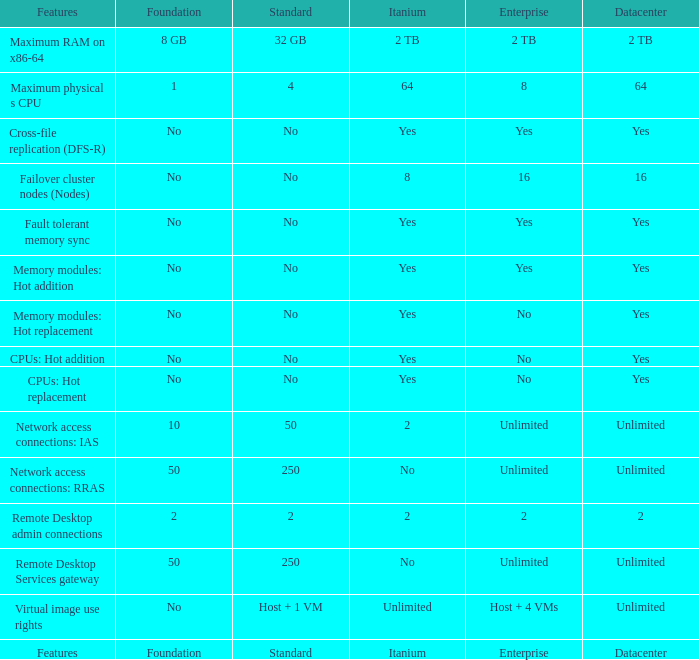What is the Enterprise for teh memory modules: hot replacement Feature that has a Datacenter of Yes? No. 